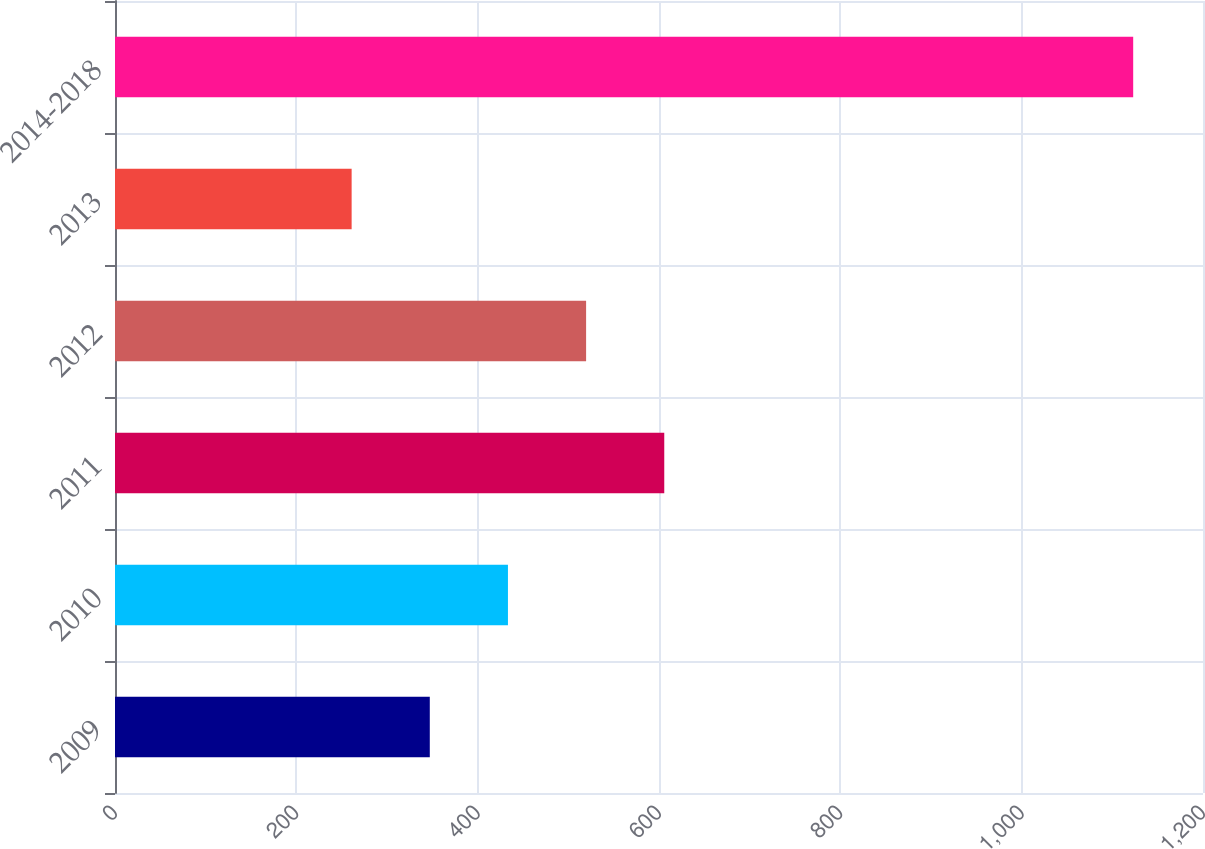Convert chart to OTSL. <chart><loc_0><loc_0><loc_500><loc_500><bar_chart><fcel>2009<fcel>2010<fcel>2011<fcel>2012<fcel>2013<fcel>2014-2018<nl><fcel>347.2<fcel>433.4<fcel>605.8<fcel>519.6<fcel>261<fcel>1123<nl></chart> 